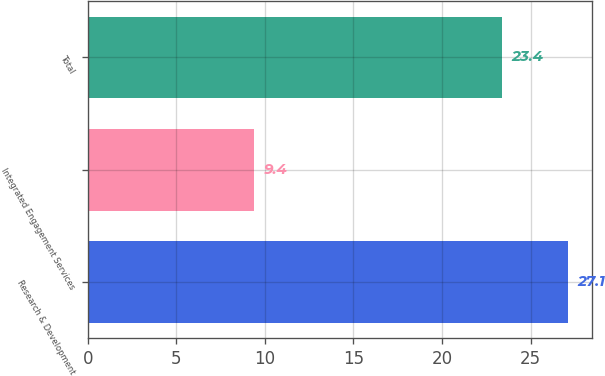Convert chart. <chart><loc_0><loc_0><loc_500><loc_500><bar_chart><fcel>Research & Development<fcel>Integrated Engagement Services<fcel>Total<nl><fcel>27.1<fcel>9.4<fcel>23.4<nl></chart> 